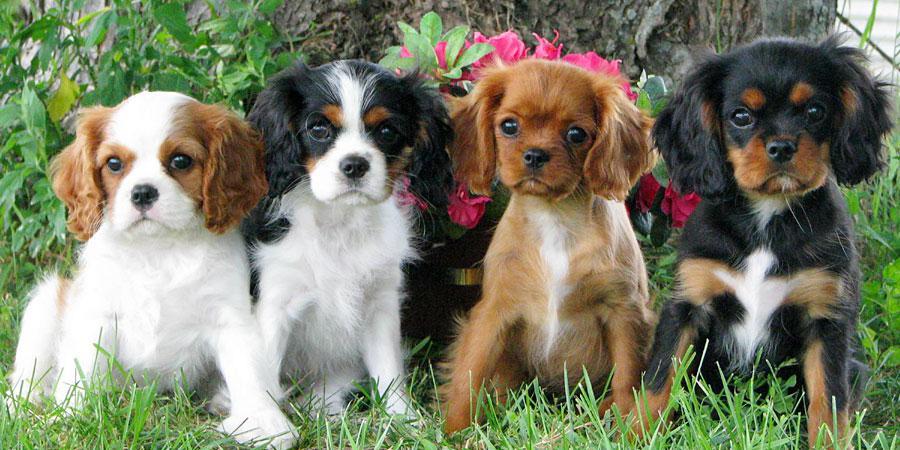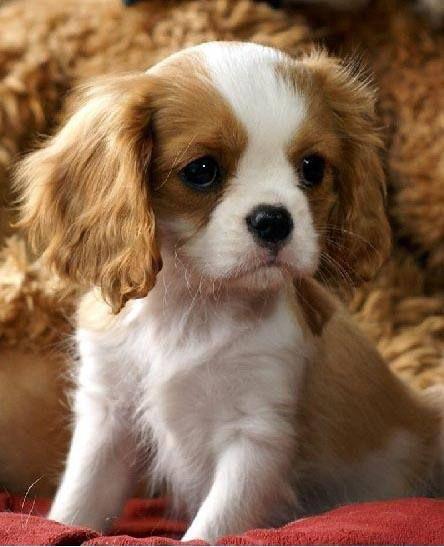The first image is the image on the left, the second image is the image on the right. Evaluate the accuracy of this statement regarding the images: "There are no more than four cocker spaniels". Is it true? Answer yes or no. No. The first image is the image on the left, the second image is the image on the right. Assess this claim about the two images: "One image features exactly two puppies, one brown and white, and the other black, brown and white.". Correct or not? Answer yes or no. No. 